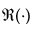<formula> <loc_0><loc_0><loc_500><loc_500>\Re ( \cdot )</formula> 